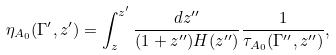Convert formula to latex. <formula><loc_0><loc_0><loc_500><loc_500>\eta _ { A _ { 0 } } ( \Gamma ^ { \prime } , z ^ { \prime } ) = \int _ { z } ^ { z ^ { \prime } } \frac { d z ^ { \prime \prime } } { ( 1 + z ^ { \prime \prime } ) H ( z ^ { \prime \prime } ) } \frac { 1 } { \tau _ { A _ { 0 } } ( \Gamma ^ { \prime \prime } , z ^ { \prime \prime } ) } ,</formula> 